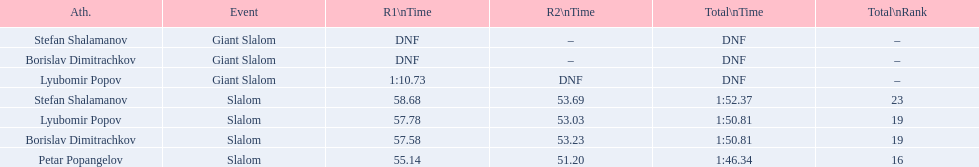Which athletes had consecutive times under 58 for both races? Lyubomir Popov, Borislav Dimitrachkov, Petar Popangelov. 